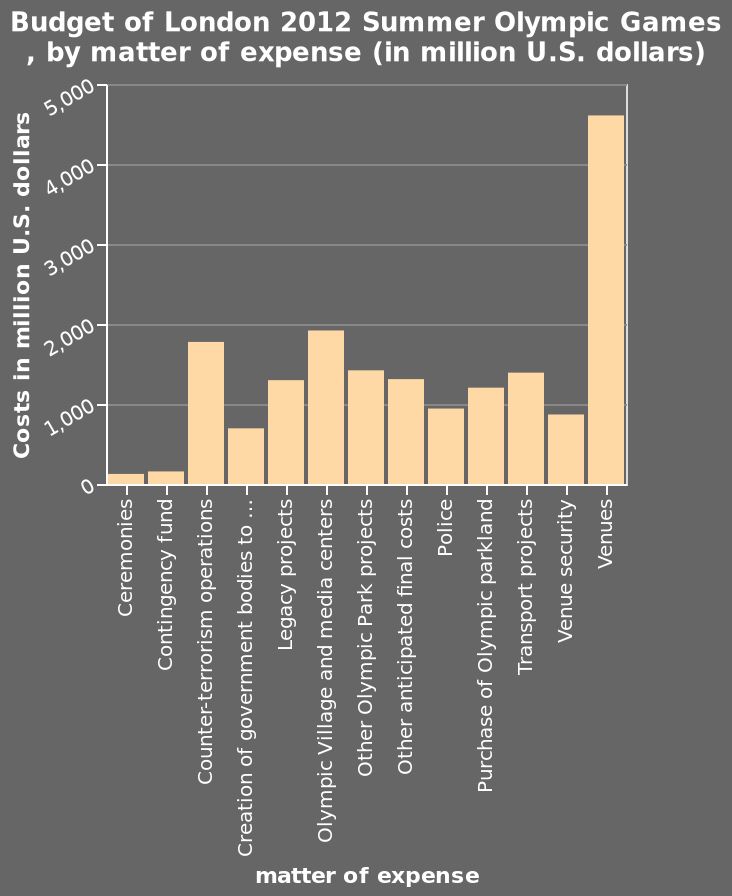<image>
What does the x-axis represent on the bar graph? The x-axis on the bar graph represents the matter of expense. 